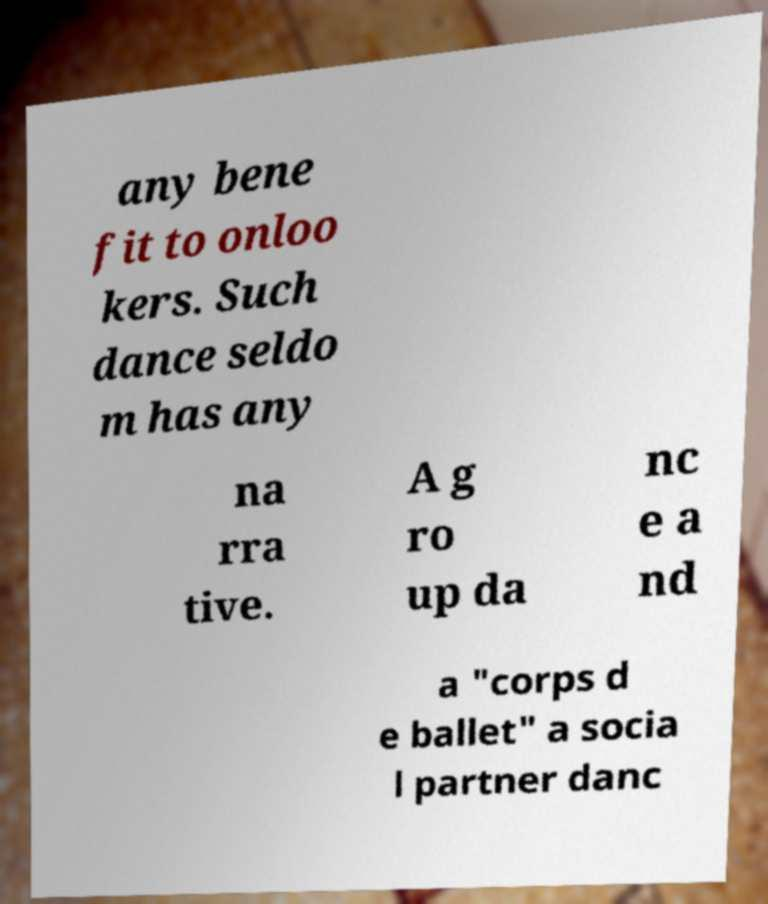What messages or text are displayed in this image? I need them in a readable, typed format. any bene fit to onloo kers. Such dance seldo m has any na rra tive. A g ro up da nc e a nd a "corps d e ballet" a socia l partner danc 